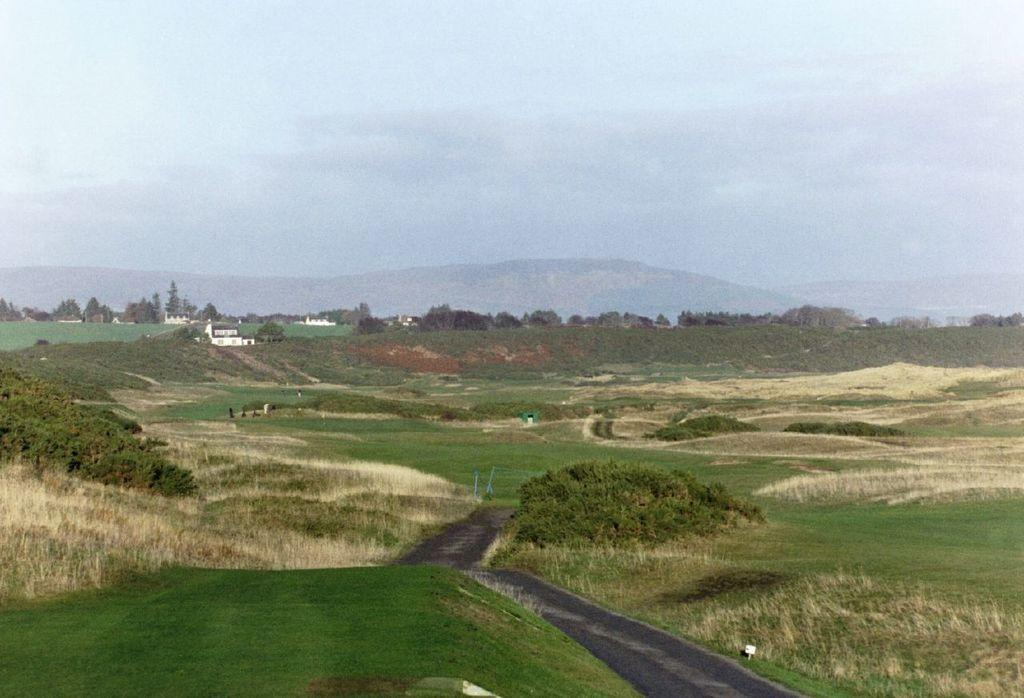What type of vegetation is present in the image? There is grass in the image. What other natural elements can be seen in the image? There are trees in the image. Are there any man-made structures visible in the image? Yes, there are buildings in the image. What type of terrain is depicted in the image? There are hills in the image. What is visible in the background of the image? The sky is visible in the background of the image. How many fish can be seen swimming in the grass in the image? There are no fish present in the image; it features grass, trees, buildings, hills, and the sky. 